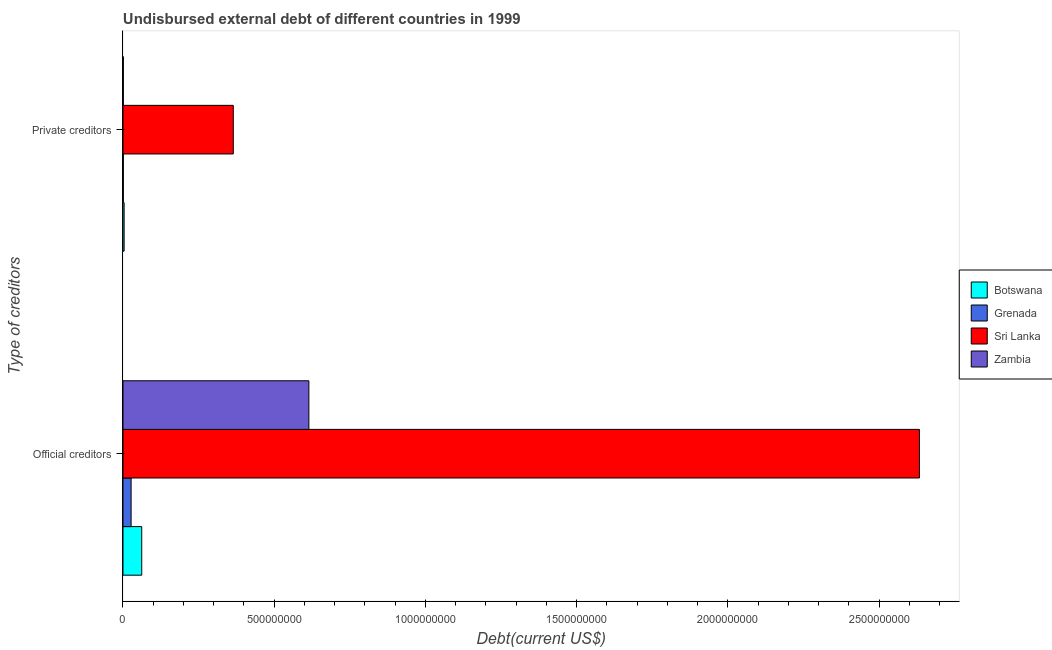How many different coloured bars are there?
Provide a succinct answer. 4. How many groups of bars are there?
Provide a short and direct response. 2. Are the number of bars per tick equal to the number of legend labels?
Make the answer very short. Yes. Are the number of bars on each tick of the Y-axis equal?
Your answer should be very brief. Yes. What is the label of the 1st group of bars from the top?
Offer a very short reply. Private creditors. What is the undisbursed external debt of official creditors in Botswana?
Make the answer very short. 6.20e+07. Across all countries, what is the maximum undisbursed external debt of private creditors?
Offer a terse response. 3.65e+08. Across all countries, what is the minimum undisbursed external debt of private creditors?
Make the answer very short. 1.17e+06. In which country was the undisbursed external debt of official creditors maximum?
Your answer should be compact. Sri Lanka. In which country was the undisbursed external debt of official creditors minimum?
Provide a succinct answer. Grenada. What is the total undisbursed external debt of official creditors in the graph?
Provide a succinct answer. 3.34e+09. What is the difference between the undisbursed external debt of private creditors in Zambia and that in Sri Lanka?
Ensure brevity in your answer.  -3.63e+08. What is the difference between the undisbursed external debt of official creditors in Sri Lanka and the undisbursed external debt of private creditors in Botswana?
Your response must be concise. 2.63e+09. What is the average undisbursed external debt of private creditors per country?
Offer a very short reply. 9.27e+07. What is the difference between the undisbursed external debt of private creditors and undisbursed external debt of official creditors in Botswana?
Your answer should be very brief. -5.82e+07. What is the ratio of the undisbursed external debt of official creditors in Zambia to that in Botswana?
Ensure brevity in your answer.  9.91. In how many countries, is the undisbursed external debt of private creditors greater than the average undisbursed external debt of private creditors taken over all countries?
Your answer should be compact. 1. What does the 1st bar from the top in Private creditors represents?
Make the answer very short. Zambia. What does the 3rd bar from the bottom in Official creditors represents?
Make the answer very short. Sri Lanka. Are all the bars in the graph horizontal?
Keep it short and to the point. Yes. How many countries are there in the graph?
Provide a short and direct response. 4. What is the difference between two consecutive major ticks on the X-axis?
Your response must be concise. 5.00e+08. Are the values on the major ticks of X-axis written in scientific E-notation?
Offer a terse response. No. Does the graph contain grids?
Provide a succinct answer. No. How many legend labels are there?
Give a very brief answer. 4. How are the legend labels stacked?
Your answer should be very brief. Vertical. What is the title of the graph?
Keep it short and to the point. Undisbursed external debt of different countries in 1999. What is the label or title of the X-axis?
Make the answer very short. Debt(current US$). What is the label or title of the Y-axis?
Ensure brevity in your answer.  Type of creditors. What is the Debt(current US$) in Botswana in Official creditors?
Ensure brevity in your answer.  6.20e+07. What is the Debt(current US$) of Grenada in Official creditors?
Offer a terse response. 2.69e+07. What is the Debt(current US$) of Sri Lanka in Official creditors?
Ensure brevity in your answer.  2.63e+09. What is the Debt(current US$) of Zambia in Official creditors?
Your answer should be compact. 6.15e+08. What is the Debt(current US$) in Botswana in Private creditors?
Offer a terse response. 3.77e+06. What is the Debt(current US$) in Grenada in Private creditors?
Provide a short and direct response. 1.17e+06. What is the Debt(current US$) of Sri Lanka in Private creditors?
Ensure brevity in your answer.  3.65e+08. What is the Debt(current US$) of Zambia in Private creditors?
Provide a short and direct response. 1.21e+06. Across all Type of creditors, what is the maximum Debt(current US$) of Botswana?
Give a very brief answer. 6.20e+07. Across all Type of creditors, what is the maximum Debt(current US$) of Grenada?
Provide a succinct answer. 2.69e+07. Across all Type of creditors, what is the maximum Debt(current US$) in Sri Lanka?
Make the answer very short. 2.63e+09. Across all Type of creditors, what is the maximum Debt(current US$) in Zambia?
Offer a very short reply. 6.15e+08. Across all Type of creditors, what is the minimum Debt(current US$) in Botswana?
Ensure brevity in your answer.  3.77e+06. Across all Type of creditors, what is the minimum Debt(current US$) of Grenada?
Ensure brevity in your answer.  1.17e+06. Across all Type of creditors, what is the minimum Debt(current US$) of Sri Lanka?
Offer a terse response. 3.65e+08. Across all Type of creditors, what is the minimum Debt(current US$) of Zambia?
Make the answer very short. 1.21e+06. What is the total Debt(current US$) of Botswana in the graph?
Your answer should be very brief. 6.58e+07. What is the total Debt(current US$) in Grenada in the graph?
Provide a short and direct response. 2.80e+07. What is the total Debt(current US$) in Sri Lanka in the graph?
Offer a terse response. 3.00e+09. What is the total Debt(current US$) of Zambia in the graph?
Your response must be concise. 6.16e+08. What is the difference between the Debt(current US$) in Botswana in Official creditors and that in Private creditors?
Give a very brief answer. 5.82e+07. What is the difference between the Debt(current US$) in Grenada in Official creditors and that in Private creditors?
Keep it short and to the point. 2.57e+07. What is the difference between the Debt(current US$) of Sri Lanka in Official creditors and that in Private creditors?
Your answer should be very brief. 2.27e+09. What is the difference between the Debt(current US$) in Zambia in Official creditors and that in Private creditors?
Your answer should be very brief. 6.13e+08. What is the difference between the Debt(current US$) in Botswana in Official creditors and the Debt(current US$) in Grenada in Private creditors?
Provide a short and direct response. 6.08e+07. What is the difference between the Debt(current US$) of Botswana in Official creditors and the Debt(current US$) of Sri Lanka in Private creditors?
Ensure brevity in your answer.  -3.03e+08. What is the difference between the Debt(current US$) in Botswana in Official creditors and the Debt(current US$) in Zambia in Private creditors?
Offer a terse response. 6.08e+07. What is the difference between the Debt(current US$) in Grenada in Official creditors and the Debt(current US$) in Sri Lanka in Private creditors?
Offer a terse response. -3.38e+08. What is the difference between the Debt(current US$) of Grenada in Official creditors and the Debt(current US$) of Zambia in Private creditors?
Offer a terse response. 2.56e+07. What is the difference between the Debt(current US$) of Sri Lanka in Official creditors and the Debt(current US$) of Zambia in Private creditors?
Provide a short and direct response. 2.63e+09. What is the average Debt(current US$) in Botswana per Type of creditors?
Provide a succinct answer. 3.29e+07. What is the average Debt(current US$) in Grenada per Type of creditors?
Your answer should be very brief. 1.40e+07. What is the average Debt(current US$) of Sri Lanka per Type of creditors?
Provide a short and direct response. 1.50e+09. What is the average Debt(current US$) in Zambia per Type of creditors?
Provide a succinct answer. 3.08e+08. What is the difference between the Debt(current US$) of Botswana and Debt(current US$) of Grenada in Official creditors?
Keep it short and to the point. 3.51e+07. What is the difference between the Debt(current US$) in Botswana and Debt(current US$) in Sri Lanka in Official creditors?
Provide a succinct answer. -2.57e+09. What is the difference between the Debt(current US$) of Botswana and Debt(current US$) of Zambia in Official creditors?
Give a very brief answer. -5.53e+08. What is the difference between the Debt(current US$) of Grenada and Debt(current US$) of Sri Lanka in Official creditors?
Ensure brevity in your answer.  -2.61e+09. What is the difference between the Debt(current US$) in Grenada and Debt(current US$) in Zambia in Official creditors?
Provide a short and direct response. -5.88e+08. What is the difference between the Debt(current US$) in Sri Lanka and Debt(current US$) in Zambia in Official creditors?
Offer a terse response. 2.02e+09. What is the difference between the Debt(current US$) of Botswana and Debt(current US$) of Grenada in Private creditors?
Offer a very short reply. 2.61e+06. What is the difference between the Debt(current US$) of Botswana and Debt(current US$) of Sri Lanka in Private creditors?
Make the answer very short. -3.61e+08. What is the difference between the Debt(current US$) in Botswana and Debt(current US$) in Zambia in Private creditors?
Offer a terse response. 2.56e+06. What is the difference between the Debt(current US$) in Grenada and Debt(current US$) in Sri Lanka in Private creditors?
Provide a succinct answer. -3.63e+08. What is the difference between the Debt(current US$) of Grenada and Debt(current US$) of Zambia in Private creditors?
Provide a succinct answer. -4.80e+04. What is the difference between the Debt(current US$) in Sri Lanka and Debt(current US$) in Zambia in Private creditors?
Give a very brief answer. 3.63e+08. What is the ratio of the Debt(current US$) in Botswana in Official creditors to that in Private creditors?
Your answer should be compact. 16.44. What is the ratio of the Debt(current US$) of Grenada in Official creditors to that in Private creditors?
Offer a very short reply. 23.04. What is the ratio of the Debt(current US$) in Sri Lanka in Official creditors to that in Private creditors?
Your response must be concise. 7.22. What is the ratio of the Debt(current US$) in Zambia in Official creditors to that in Private creditors?
Provide a short and direct response. 506.23. What is the difference between the highest and the second highest Debt(current US$) in Botswana?
Your answer should be compact. 5.82e+07. What is the difference between the highest and the second highest Debt(current US$) in Grenada?
Offer a terse response. 2.57e+07. What is the difference between the highest and the second highest Debt(current US$) of Sri Lanka?
Your response must be concise. 2.27e+09. What is the difference between the highest and the second highest Debt(current US$) in Zambia?
Make the answer very short. 6.13e+08. What is the difference between the highest and the lowest Debt(current US$) in Botswana?
Ensure brevity in your answer.  5.82e+07. What is the difference between the highest and the lowest Debt(current US$) in Grenada?
Make the answer very short. 2.57e+07. What is the difference between the highest and the lowest Debt(current US$) of Sri Lanka?
Your response must be concise. 2.27e+09. What is the difference between the highest and the lowest Debt(current US$) of Zambia?
Your response must be concise. 6.13e+08. 